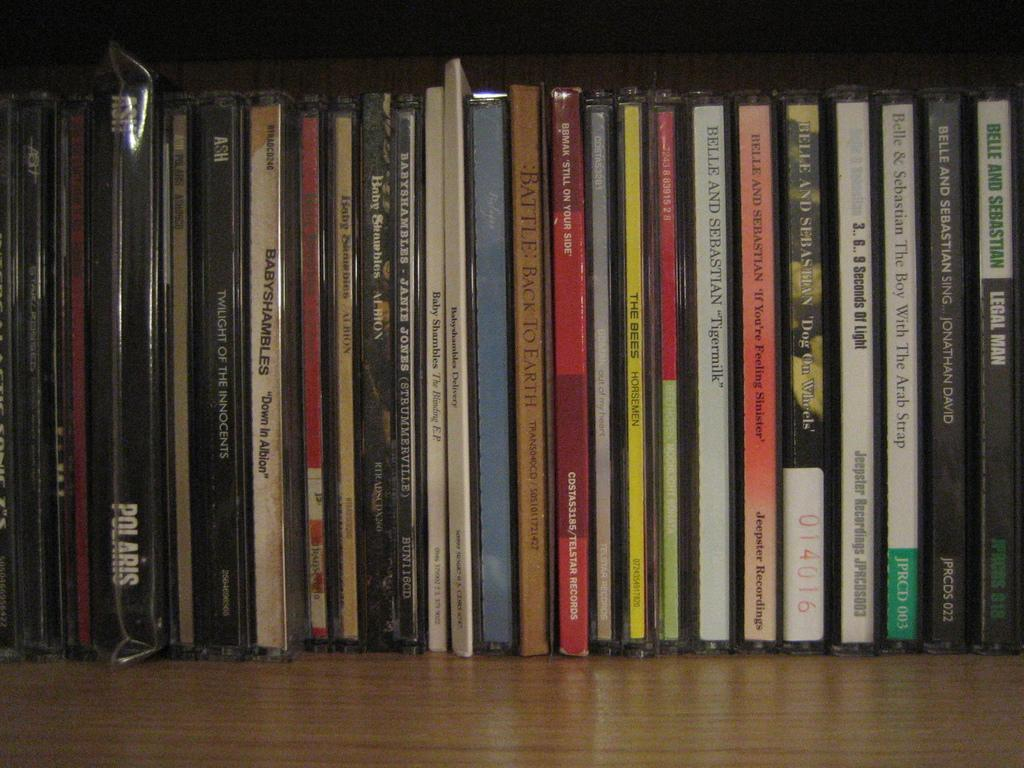Provide a one-sentence caption for the provided image. A persons alphabetized cd collection mostly consisting of Belle and Sebastian. 